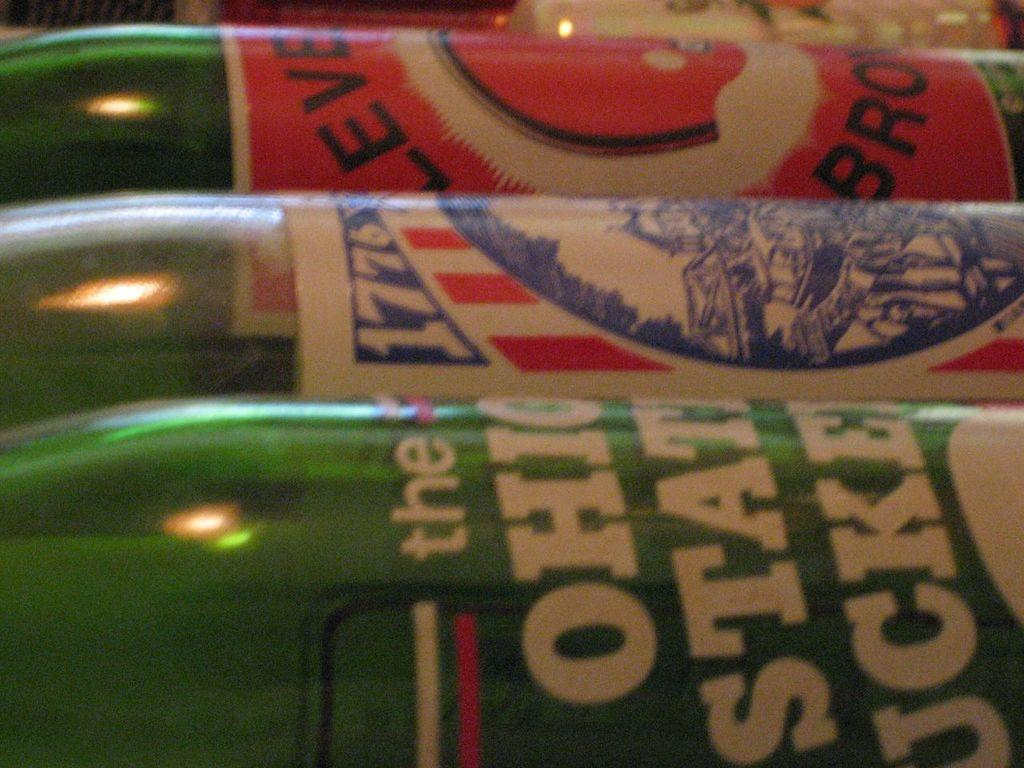Provide a one-sentence caption for the provided image. Novelty bottles of soda are on their side, one reads Ohio State Buckeyes. 